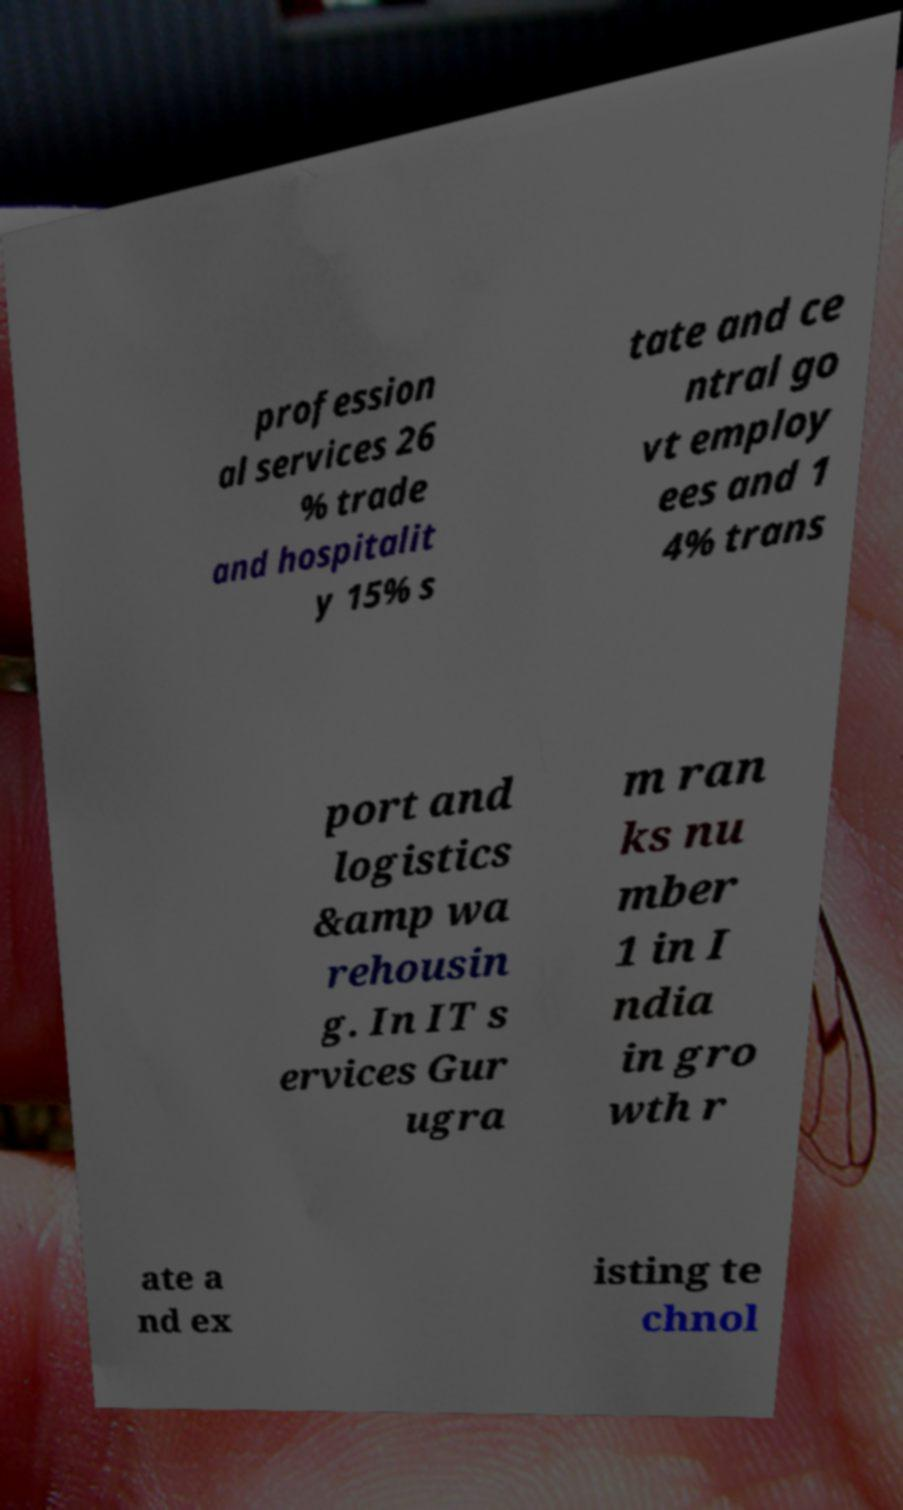For documentation purposes, I need the text within this image transcribed. Could you provide that? profession al services 26 % trade and hospitalit y 15% s tate and ce ntral go vt employ ees and 1 4% trans port and logistics &amp wa rehousin g. In IT s ervices Gur ugra m ran ks nu mber 1 in I ndia in gro wth r ate a nd ex isting te chnol 